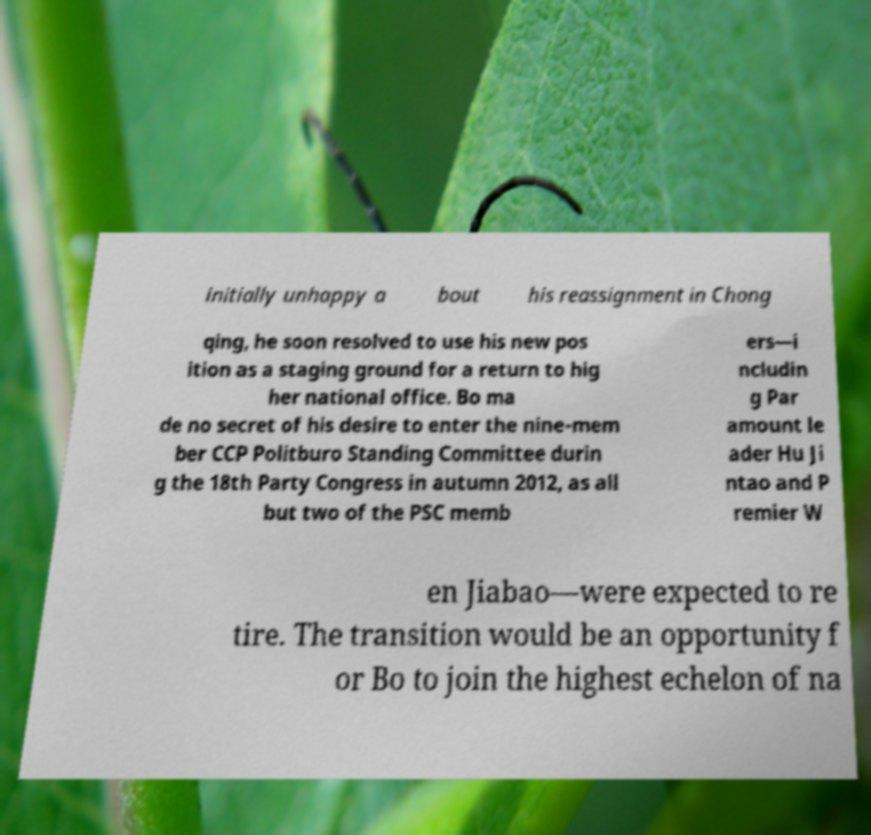There's text embedded in this image that I need extracted. Can you transcribe it verbatim? initially unhappy a bout his reassignment in Chong qing, he soon resolved to use his new pos ition as a staging ground for a return to hig her national office. Bo ma de no secret of his desire to enter the nine-mem ber CCP Politburo Standing Committee durin g the 18th Party Congress in autumn 2012, as all but two of the PSC memb ers—i ncludin g Par amount le ader Hu Ji ntao and P remier W en Jiabao—were expected to re tire. The transition would be an opportunity f or Bo to join the highest echelon of na 